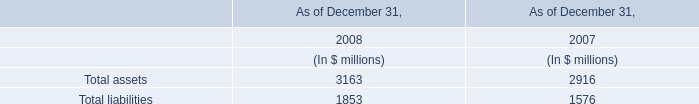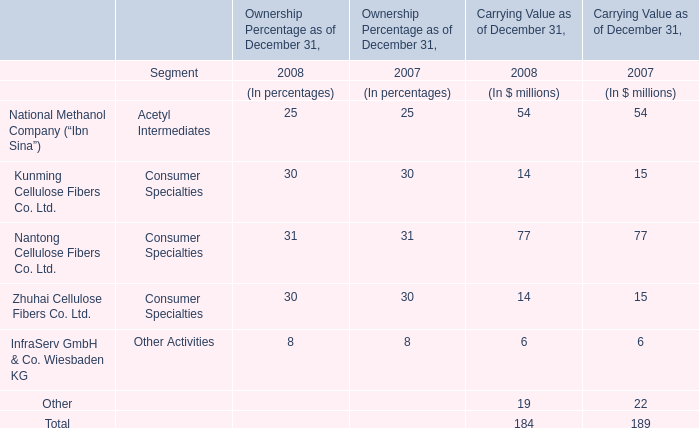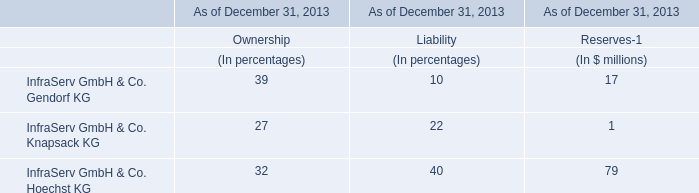what is the growth rate in dividends received in 2012 compare to 2011? 
Computations: ((83 - 78) / 78)
Answer: 0.0641. 